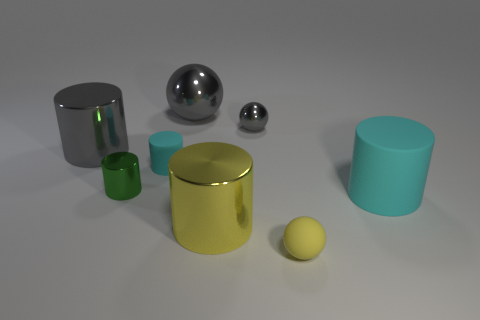Subtract 1 cylinders. How many cylinders are left? 4 Subtract all yellow cylinders. How many cylinders are left? 4 Subtract all large yellow cylinders. How many cylinders are left? 4 Subtract all blue cylinders. Subtract all brown cubes. How many cylinders are left? 5 Add 2 big red shiny cylinders. How many objects exist? 10 Subtract all cylinders. How many objects are left? 3 Add 7 large balls. How many large balls are left? 8 Add 6 green shiny cylinders. How many green shiny cylinders exist? 7 Subtract 0 blue spheres. How many objects are left? 8 Subtract all small red metal blocks. Subtract all gray cylinders. How many objects are left? 7 